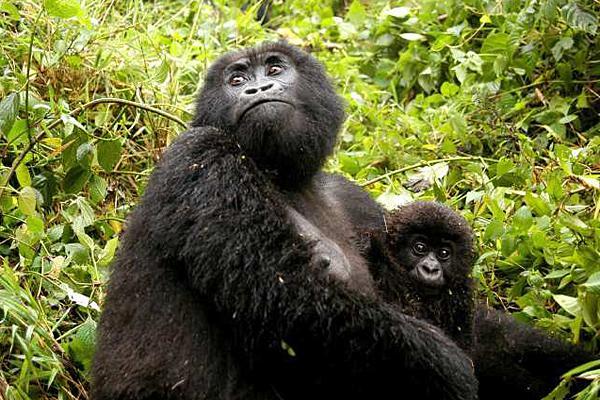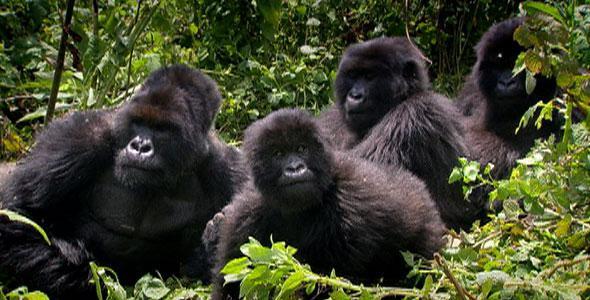The first image is the image on the left, the second image is the image on the right. Given the left and right images, does the statement "Multiple gorillas can be seen in the right image." hold true? Answer yes or no. Yes. The first image is the image on the left, the second image is the image on the right. Considering the images on both sides, is "An image includes a baby gorilla held in the arms of an adult gorilla." valid? Answer yes or no. Yes. 